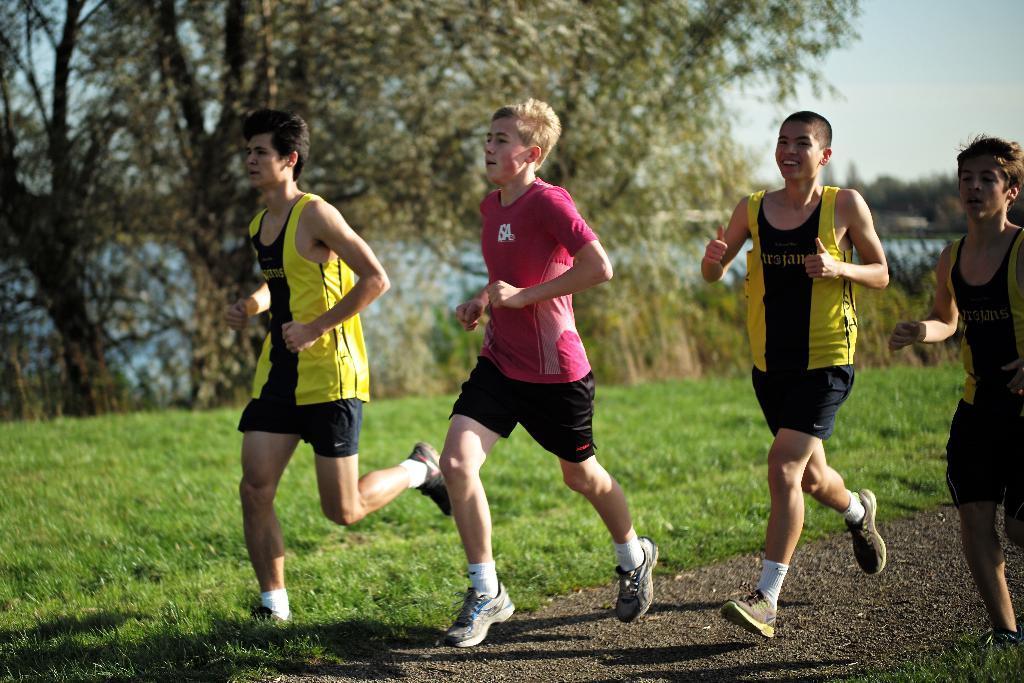Can you describe this image briefly? In the image there are few people running on the road and around them there is grass and in the background there are trees. 